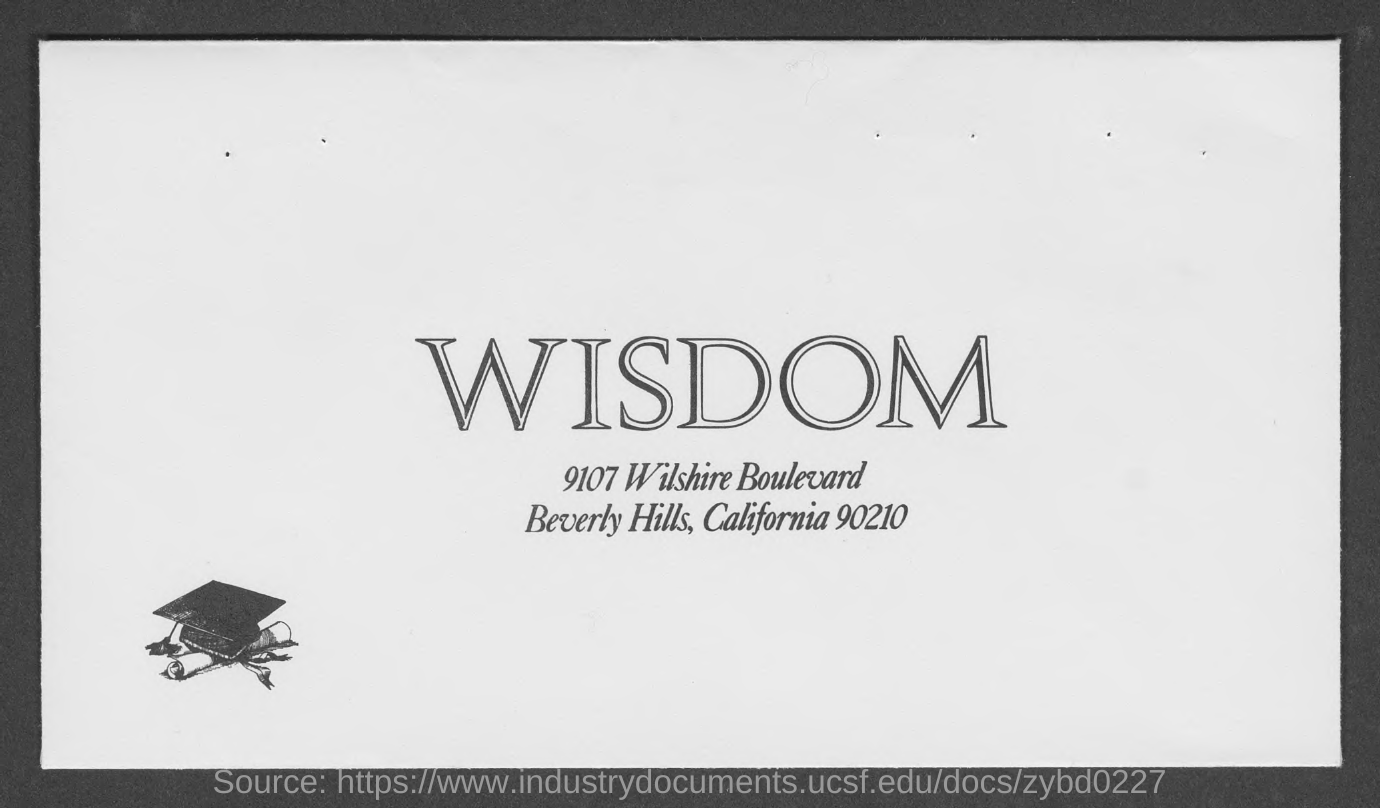Identify some key points in this picture. The document mentions a country called California. What is the ZIP code for 90210? The word written in large font is 'WISDOM'. The hills where wisdom is located are in Beverly Hills. 